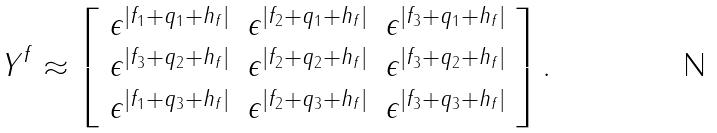Convert formula to latex. <formula><loc_0><loc_0><loc_500><loc_500>Y ^ { f } \approx \left [ \begin{array} { c c c } \epsilon ^ { | f _ { 1 } + q _ { 1 } + h _ { f } | } & \epsilon ^ { | f _ { 2 } + q _ { 1 } + h _ { f } | } & \epsilon ^ { | f _ { 3 } + q _ { 1 } + h _ { f } | } \\ \epsilon ^ { | f _ { 3 } + q _ { 2 } + h _ { f } | } & \epsilon ^ { | f _ { 2 } + q _ { 2 } + h _ { f } | } & \epsilon ^ { | f _ { 3 } + q _ { 2 } + h _ { f } | } \\ \epsilon ^ { | f _ { 1 } + q _ { 3 } + h _ { f } | } & \epsilon ^ { | f _ { 2 } + q _ { 3 } + h _ { f } | } & \epsilon ^ { | f _ { 3 } + q _ { 3 } + h _ { f } | } \end{array} \right ] .</formula> 